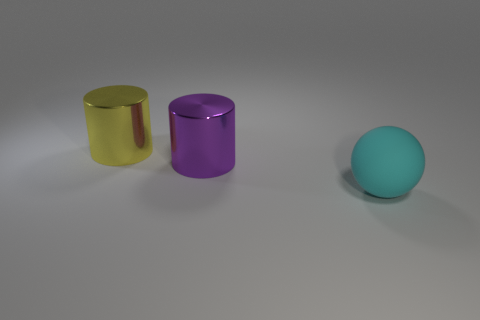Add 3 cyan matte things. How many objects exist? 6 Subtract all cylinders. How many objects are left? 1 Add 1 cyan things. How many cyan things are left? 2 Add 2 large yellow cylinders. How many large yellow cylinders exist? 3 Subtract 0 yellow balls. How many objects are left? 3 Subtract all big cylinders. Subtract all big purple objects. How many objects are left? 0 